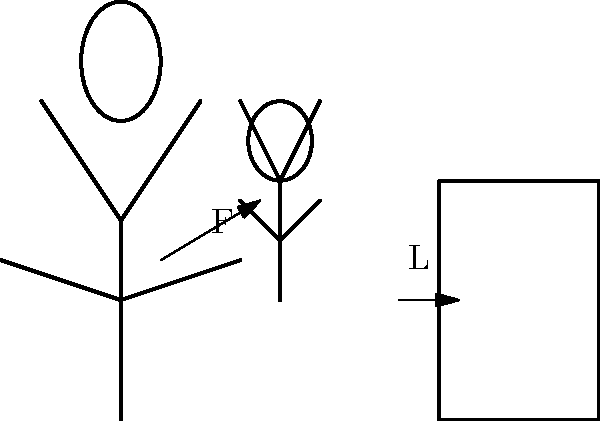When lifting a child into a car seat, what is the recommended angle (in degrees) between the upper arm and the torso to minimize the risk of back injury? To minimize the risk of back injury when lifting a child into a car seat, it's important to maintain proper biomechanics. Here's a step-by-step explanation:

1. Positioning: Stand close to the child and the car seat to reduce the moment arm.

2. Foot placement: Keep feet shoulder-width apart for a stable base of support.

3. Squat down: Bend at the knees and hips, keeping the back straight. This engages the strong leg muscles instead of relying on the back.

4. Arm position: The recommended angle between the upper arm and torso is approximately 45 degrees. This angle allows for:
   a) Optimal force generation from the shoulder muscles
   b) Reduced strain on the rotator cuff
   c) Improved leverage for lifting

5. Lift technique: 
   a) Grasp the child securely
   b) Keep the child close to your body
   c) Lift by straightening your legs, keeping your back straight
   d) Avoid twisting; instead, pivot with your feet

6. Transfer to car seat:
   a) Step towards the car seat
   b) Lower the child into the seat using your leg muscles
   c) Maintain the 45-degree arm angle throughout the movement

By maintaining this 45-degree angle, you create an efficient lever system that distributes the force between your arms and torso, reducing the load on your lower back and minimizing the risk of injury.
Answer: 45 degrees 